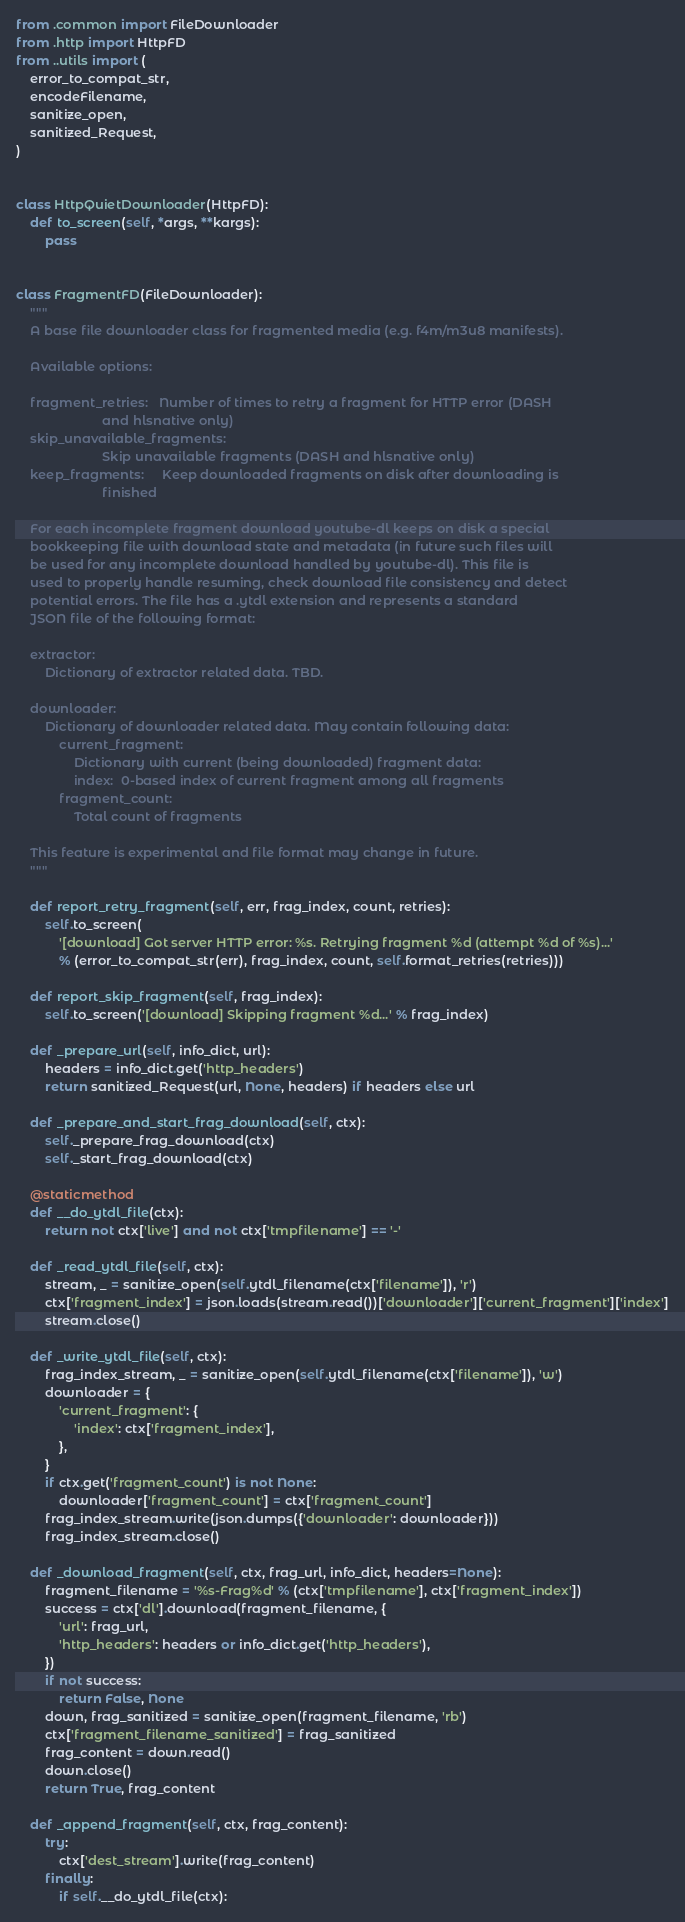Convert code to text. <code><loc_0><loc_0><loc_500><loc_500><_Python_>from .common import FileDownloader
from .http import HttpFD
from ..utils import (
    error_to_compat_str,
    encodeFilename,
    sanitize_open,
    sanitized_Request,
)


class HttpQuietDownloader(HttpFD):
    def to_screen(self, *args, **kargs):
        pass


class FragmentFD(FileDownloader):
    """
    A base file downloader class for fragmented media (e.g. f4m/m3u8 manifests).

    Available options:

    fragment_retries:   Number of times to retry a fragment for HTTP error (DASH
                        and hlsnative only)
    skip_unavailable_fragments:
                        Skip unavailable fragments (DASH and hlsnative only)
    keep_fragments:     Keep downloaded fragments on disk after downloading is
                        finished

    For each incomplete fragment download youtube-dl keeps on disk a special
    bookkeeping file with download state and metadata (in future such files will
    be used for any incomplete download handled by youtube-dl). This file is
    used to properly handle resuming, check download file consistency and detect
    potential errors. The file has a .ytdl extension and represents a standard
    JSON file of the following format:

    extractor:
        Dictionary of extractor related data. TBD.

    downloader:
        Dictionary of downloader related data. May contain following data:
            current_fragment:
                Dictionary with current (being downloaded) fragment data:
                index:  0-based index of current fragment among all fragments
            fragment_count:
                Total count of fragments

    This feature is experimental and file format may change in future.
    """

    def report_retry_fragment(self, err, frag_index, count, retries):
        self.to_screen(
            '[download] Got server HTTP error: %s. Retrying fragment %d (attempt %d of %s)...'
            % (error_to_compat_str(err), frag_index, count, self.format_retries(retries)))

    def report_skip_fragment(self, frag_index):
        self.to_screen('[download] Skipping fragment %d...' % frag_index)

    def _prepare_url(self, info_dict, url):
        headers = info_dict.get('http_headers')
        return sanitized_Request(url, None, headers) if headers else url

    def _prepare_and_start_frag_download(self, ctx):
        self._prepare_frag_download(ctx)
        self._start_frag_download(ctx)

    @staticmethod
    def __do_ytdl_file(ctx):
        return not ctx['live'] and not ctx['tmpfilename'] == '-'

    def _read_ytdl_file(self, ctx):
        stream, _ = sanitize_open(self.ytdl_filename(ctx['filename']), 'r')
        ctx['fragment_index'] = json.loads(stream.read())['downloader']['current_fragment']['index']
        stream.close()

    def _write_ytdl_file(self, ctx):
        frag_index_stream, _ = sanitize_open(self.ytdl_filename(ctx['filename']), 'w')
        downloader = {
            'current_fragment': {
                'index': ctx['fragment_index'],
            },
        }
        if ctx.get('fragment_count') is not None:
            downloader['fragment_count'] = ctx['fragment_count']
        frag_index_stream.write(json.dumps({'downloader': downloader}))
        frag_index_stream.close()

    def _download_fragment(self, ctx, frag_url, info_dict, headers=None):
        fragment_filename = '%s-Frag%d' % (ctx['tmpfilename'], ctx['fragment_index'])
        success = ctx['dl'].download(fragment_filename, {
            'url': frag_url,
            'http_headers': headers or info_dict.get('http_headers'),
        })
        if not success:
            return False, None
        down, frag_sanitized = sanitize_open(fragment_filename, 'rb')
        ctx['fragment_filename_sanitized'] = frag_sanitized
        frag_content = down.read()
        down.close()
        return True, frag_content

    def _append_fragment(self, ctx, frag_content):
        try:
            ctx['dest_stream'].write(frag_content)
        finally:
            if self.__do_ytdl_file(ctx):</code> 